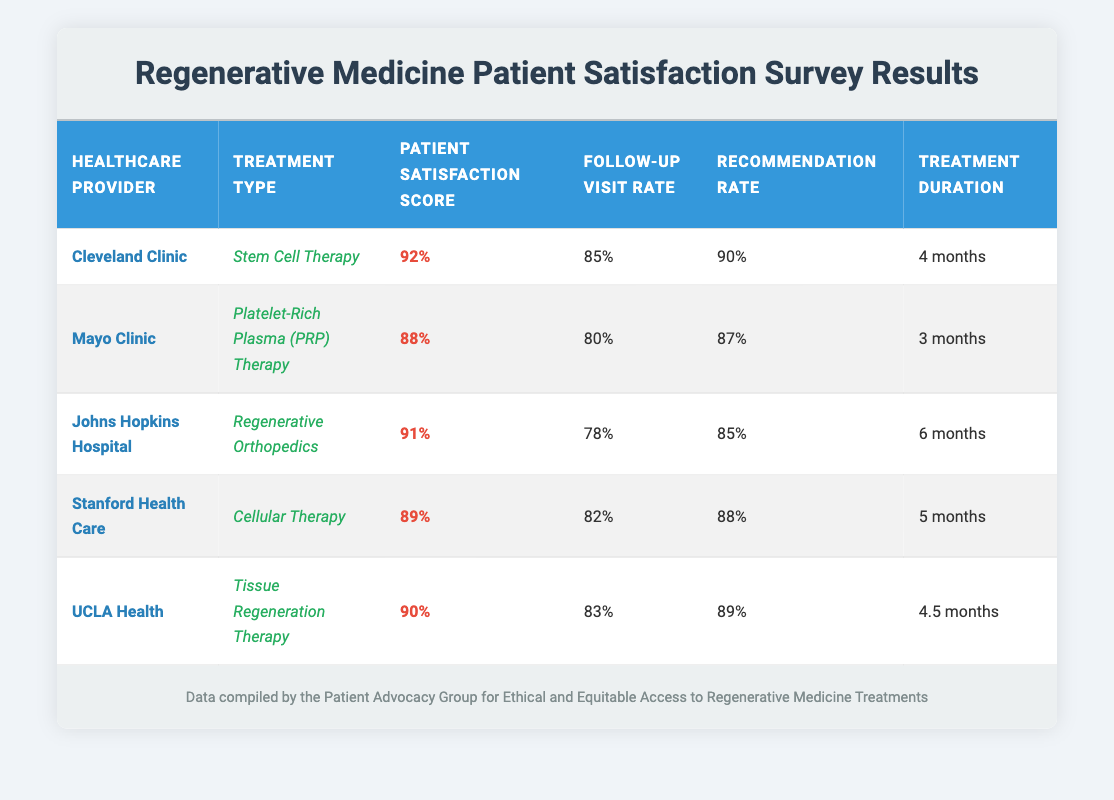What is the patient satisfaction score for Johns Hopkins Hospital? The table lists the patient satisfaction score for each healthcare provider. For Johns Hopkins Hospital, the score is directly stated under the "Patient Satisfaction Score" column as 91%.
Answer: 91% Which healthcare provider has the highest recommendation rate? By examining the "Recommendation Rate" column, I can see that Cleveland Clinic has a value of 90%, which is higher than the others (Mayo Clinic: 87%, Johns Hopkins: 85%, Stanford: 88%, UCLA: 89%). Thus, Cleveland Clinic has the highest recommendation rate.
Answer: Cleveland Clinic What is the average treatment duration across all listed providers? To find the average treatment duration, I convert the treatment durations into months, which are: 4, 3, 6, 5, and 4.5 months. I sum these values: (4 + 3 + 6 + 5 + 4.5) = 22.5 months. Then, I divide by the number of providers (5) to find the average: 22.5/5 = 4.5 months.
Answer: 4.5 months Is the follow-up visit rate for Mayo Clinic greater than the follow-up visit rate for Stanford Health Care? From the table, the follow-up visit rate for Mayo Clinic is 80%, while for Stanford Health Care it is 82%. Since 80% is less than 82%, the statement is false.
Answer: No How does the patient satisfaction score of UCLA Health compare to the average patient satisfaction score of the listed healthcare providers? The patient satisfaction scores are 92% (Cleveland Clinic), 88% (Mayo Clinic), 91% (Johns Hopkins), 89% (Stanford), and 90% (UCLA). First, I sum these scores: 92 + 88 + 91 + 89 + 90 = 450. Then, I calculate the average: 450/5 = 90%. UCLA Health's score is 90%, which is the same as the average.
Answer: Same as average 